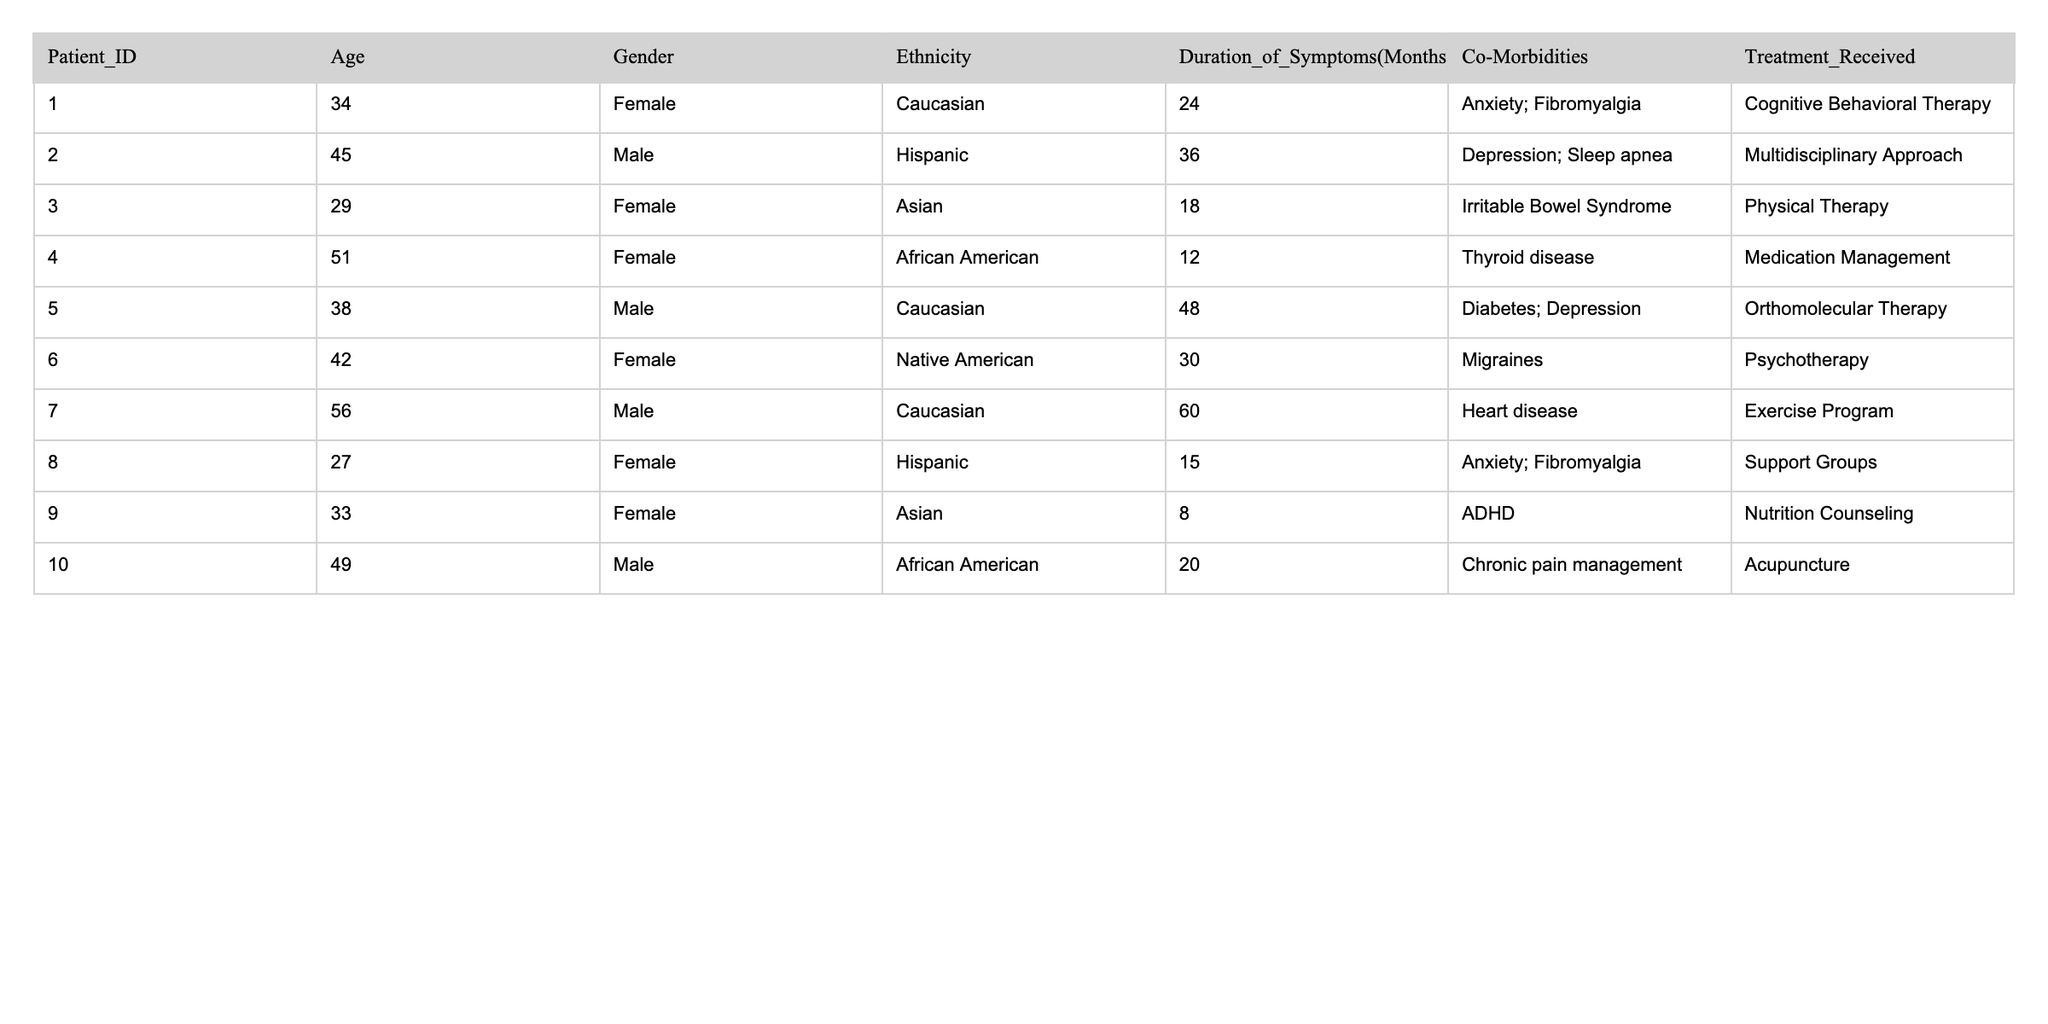What is the age of the youngest patient? The youngest patient is 27 years old, as indicated in the "Age" column for Patient_ID 8.
Answer: 27 How many patients are female? There are 5 female patients: Patients 1, 3, 4, 6, and 8 as listed in the "Gender" column.
Answer: 5 What is the most common treatment received by patients? The treatments listed are Cognitive Behavioral Therapy, Multidisciplinary Approach, Physical Therapy, Medication Management, Orthomolecular Therapy, Psychotherapy, Exercise Program, Support Groups, Nutrition Counseling, and Acupuncture. There is no clear most common treatment as they are unique to each patient.
Answer: None What is the average duration of symptoms for all patients? To calculate the average, we sum the duration of symptoms: 24 + 36 + 18 + 12 + 48 + 30 + 60 + 15 + 8 + 20 =  291. There are 10 patients, so the average is 291 / 10 = 29.1 months.
Answer: 29.1 Is there any patient who has no co-morbidities listed? All patients have at least one co-morbidity listed in the "Co-Morbidities" column, so the answer is no.
Answer: No What is the total duration of symptoms for male patients? We sum the durations for male patients (36, 48, 60, 20) to get a total of 164 months, as there are 4 male patients.
Answer: 164 How many patients received treatment focusing on mental health issues? The mental health focusing treatments are Cognitive Behavioral Therapy, Multidisciplinary Approach, Physical Therapy, Medication Management, Psychotherapy, and Support Groups, which are associated with patients 1, 2, 3, 4, 6, and 8. This totals 6 patients.
Answer: 6 What is the age difference between the oldest and the youngest patient? The oldest patient is 56 years old (Patient_ID 7), and the youngest is 27 years old (Patient_ID 8). The age difference is 56 - 27 = 29 years.
Answer: 29 Are all African American patients receiving the same treatment? The two African American patients (patients 4 and 10) receive Medication Management and Acupuncture respectively, indicating they are not receiving the same treatment.
Answer: No What percentage of patients are Caucasian? There are 3 Caucasian patients (1, 5, and 7) out of 10 total patients, resulting in a percentage of (3/10) * 100 = 30%.
Answer: 30% 